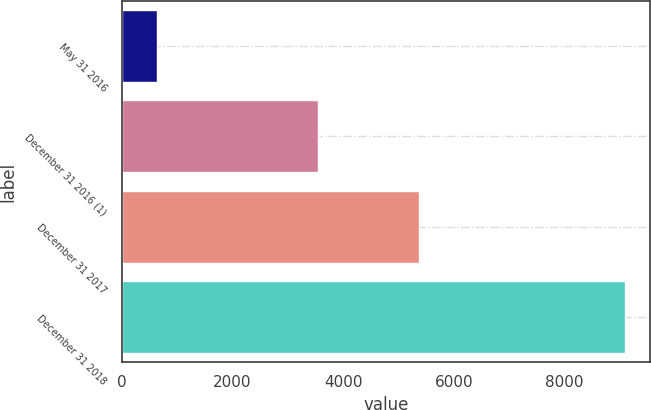Convert chart to OTSL. <chart><loc_0><loc_0><loc_500><loc_500><bar_chart><fcel>May 31 2016<fcel>December 31 2016 (1)<fcel>December 31 2017<fcel>December 31 2018<nl><fcel>630<fcel>3544<fcel>5378<fcel>9093<nl></chart> 